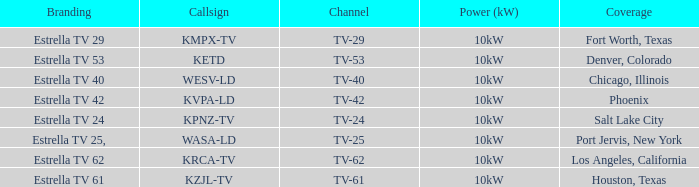List the branding name for channel tv-62. Estrella TV 62. 